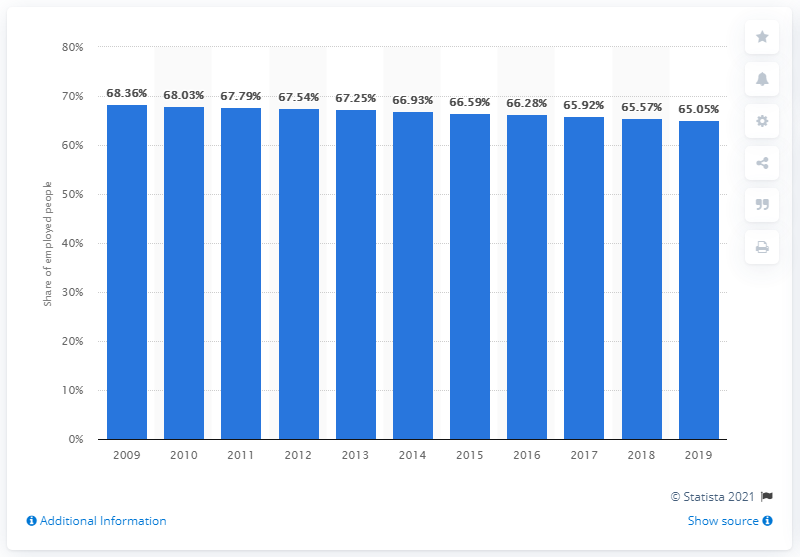Draw attention to some important aspects in this diagram. The employment rate in China in 2019 was 65.05%. In the previous year, the employment rate in China was 65.05%. 